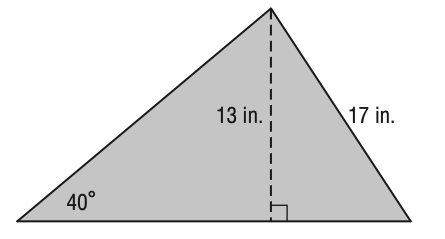Question: What is the area of the triangle below? Round your answer to the nearest tenth if necessary.
Choices:
A. 110.5
B. 144.2
C. 164.5
D. 171.9
Answer with the letter. Answer: D 